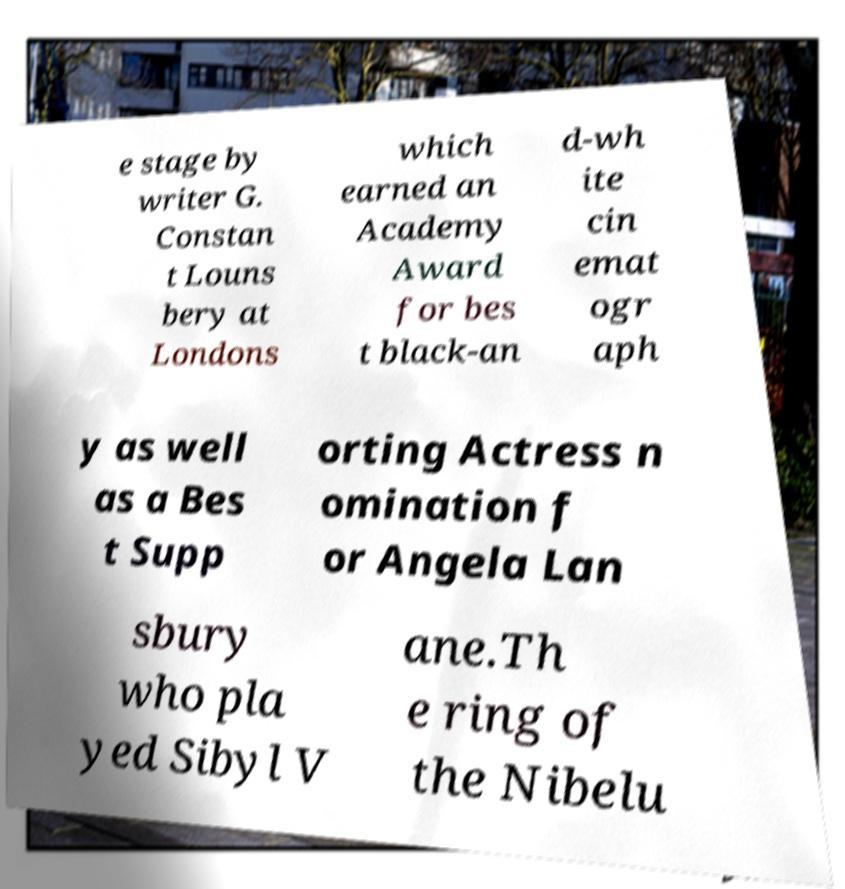Can you accurately transcribe the text from the provided image for me? e stage by writer G. Constan t Louns bery at Londons which earned an Academy Award for bes t black-an d-wh ite cin emat ogr aph y as well as a Bes t Supp orting Actress n omination f or Angela Lan sbury who pla yed Sibyl V ane.Th e ring of the Nibelu 